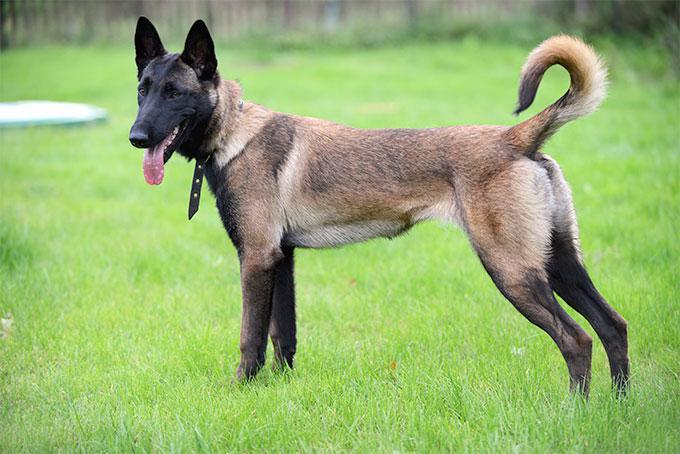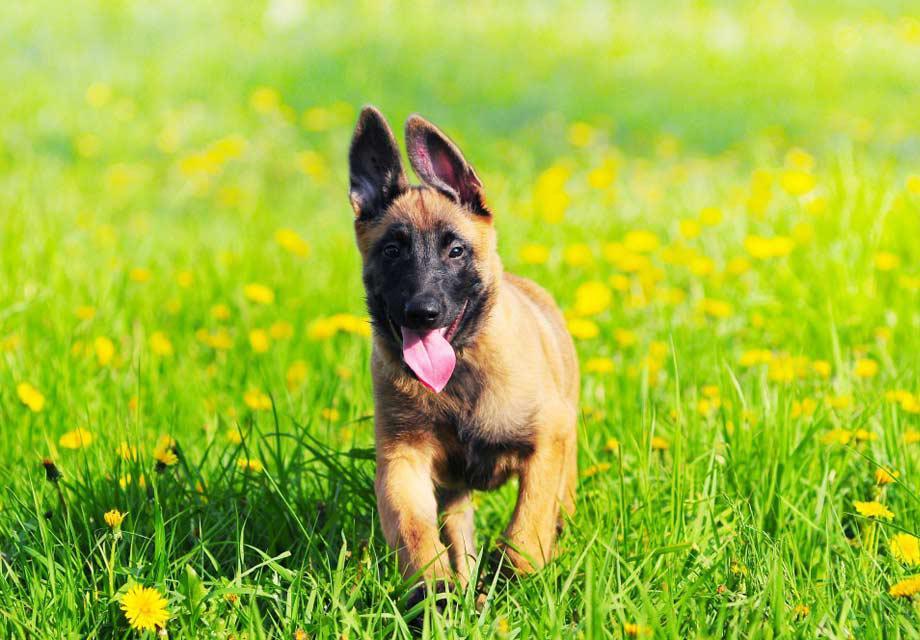The first image is the image on the left, the second image is the image on the right. Examine the images to the left and right. Is the description "One of the dogs is wearing a black collar." accurate? Answer yes or no. Yes. 